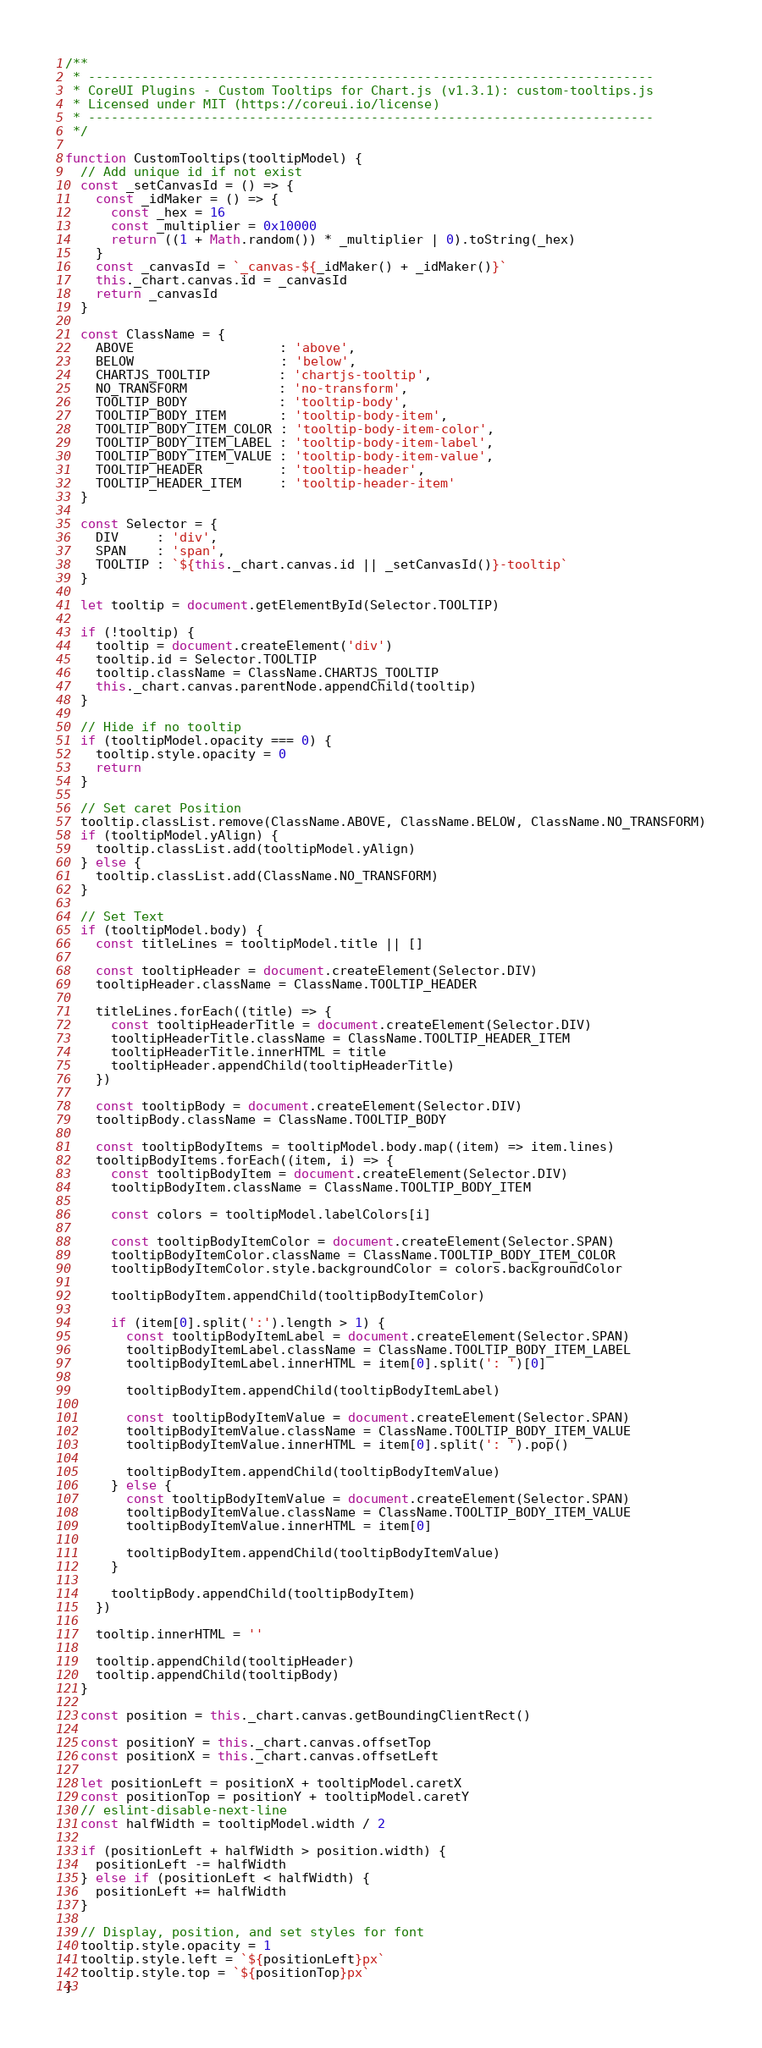Convert code to text. <code><loc_0><loc_0><loc_500><loc_500><_JavaScript_>/**
 * --------------------------------------------------------------------------
 * CoreUI Plugins - Custom Tooltips for Chart.js (v1.3.1): custom-tooltips.js
 * Licensed under MIT (https://coreui.io/license)
 * --------------------------------------------------------------------------
 */

function CustomTooltips(tooltipModel) {
  // Add unique id if not exist
  const _setCanvasId = () => {
    const _idMaker = () => {
      const _hex = 16
      const _multiplier = 0x10000
      return ((1 + Math.random()) * _multiplier | 0).toString(_hex)
    }
    const _canvasId = `_canvas-${_idMaker() + _idMaker()}`
    this._chart.canvas.id = _canvasId
    return _canvasId
  }

  const ClassName = {
    ABOVE                   : 'above',
    BELOW                   : 'below',
    CHARTJS_TOOLTIP         : 'chartjs-tooltip',
    NO_TRANSFORM            : 'no-transform',
    TOOLTIP_BODY            : 'tooltip-body',
    TOOLTIP_BODY_ITEM       : 'tooltip-body-item',
    TOOLTIP_BODY_ITEM_COLOR : 'tooltip-body-item-color',
    TOOLTIP_BODY_ITEM_LABEL : 'tooltip-body-item-label',
    TOOLTIP_BODY_ITEM_VALUE : 'tooltip-body-item-value',
    TOOLTIP_HEADER          : 'tooltip-header',
    TOOLTIP_HEADER_ITEM     : 'tooltip-header-item'
  }

  const Selector = {
    DIV     : 'div',
    SPAN    : 'span',
    TOOLTIP : `${this._chart.canvas.id || _setCanvasId()}-tooltip`
  }

  let tooltip = document.getElementById(Selector.TOOLTIP)

  if (!tooltip) {
    tooltip = document.createElement('div')
    tooltip.id = Selector.TOOLTIP
    tooltip.className = ClassName.CHARTJS_TOOLTIP
    this._chart.canvas.parentNode.appendChild(tooltip)
  }

  // Hide if no tooltip
  if (tooltipModel.opacity === 0) {
    tooltip.style.opacity = 0
    return
  }

  // Set caret Position
  tooltip.classList.remove(ClassName.ABOVE, ClassName.BELOW, ClassName.NO_TRANSFORM)
  if (tooltipModel.yAlign) {
    tooltip.classList.add(tooltipModel.yAlign)
  } else {
    tooltip.classList.add(ClassName.NO_TRANSFORM)
  }

  // Set Text
  if (tooltipModel.body) {
    const titleLines = tooltipModel.title || []

    const tooltipHeader = document.createElement(Selector.DIV)
    tooltipHeader.className = ClassName.TOOLTIP_HEADER

    titleLines.forEach((title) => {
      const tooltipHeaderTitle = document.createElement(Selector.DIV)
      tooltipHeaderTitle.className = ClassName.TOOLTIP_HEADER_ITEM
      tooltipHeaderTitle.innerHTML = title
      tooltipHeader.appendChild(tooltipHeaderTitle)
    })

    const tooltipBody = document.createElement(Selector.DIV)
    tooltipBody.className = ClassName.TOOLTIP_BODY

    const tooltipBodyItems = tooltipModel.body.map((item) => item.lines)
    tooltipBodyItems.forEach((item, i) => {
      const tooltipBodyItem = document.createElement(Selector.DIV)
      tooltipBodyItem.className = ClassName.TOOLTIP_BODY_ITEM

      const colors = tooltipModel.labelColors[i]

      const tooltipBodyItemColor = document.createElement(Selector.SPAN)
      tooltipBodyItemColor.className = ClassName.TOOLTIP_BODY_ITEM_COLOR
      tooltipBodyItemColor.style.backgroundColor = colors.backgroundColor

      tooltipBodyItem.appendChild(tooltipBodyItemColor)

      if (item[0].split(':').length > 1) {
        const tooltipBodyItemLabel = document.createElement(Selector.SPAN)
        tooltipBodyItemLabel.className = ClassName.TOOLTIP_BODY_ITEM_LABEL
        tooltipBodyItemLabel.innerHTML = item[0].split(': ')[0]

        tooltipBodyItem.appendChild(tooltipBodyItemLabel)

        const tooltipBodyItemValue = document.createElement(Selector.SPAN)
        tooltipBodyItemValue.className = ClassName.TOOLTIP_BODY_ITEM_VALUE
        tooltipBodyItemValue.innerHTML = item[0].split(': ').pop()

        tooltipBodyItem.appendChild(tooltipBodyItemValue)
      } else {
        const tooltipBodyItemValue = document.createElement(Selector.SPAN)
        tooltipBodyItemValue.className = ClassName.TOOLTIP_BODY_ITEM_VALUE
        tooltipBodyItemValue.innerHTML = item[0]

        tooltipBodyItem.appendChild(tooltipBodyItemValue)
      }

      tooltipBody.appendChild(tooltipBodyItem)
    })

    tooltip.innerHTML = ''

    tooltip.appendChild(tooltipHeader)
    tooltip.appendChild(tooltipBody)
  }

  const position = this._chart.canvas.getBoundingClientRect()

  const positionY = this._chart.canvas.offsetTop
  const positionX = this._chart.canvas.offsetLeft

  let positionLeft = positionX + tooltipModel.caretX
  const positionTop = positionY + tooltipModel.caretY
  // eslint-disable-next-line
  const halfWidth = tooltipModel.width / 2

  if (positionLeft + halfWidth > position.width) {
    positionLeft -= halfWidth
  } else if (positionLeft < halfWidth) {
    positionLeft += halfWidth
  }

  // Display, position, and set styles for font
  tooltip.style.opacity = 1
  tooltip.style.left = `${positionLeft}px`
  tooltip.style.top = `${positionTop}px`
}
</code> 